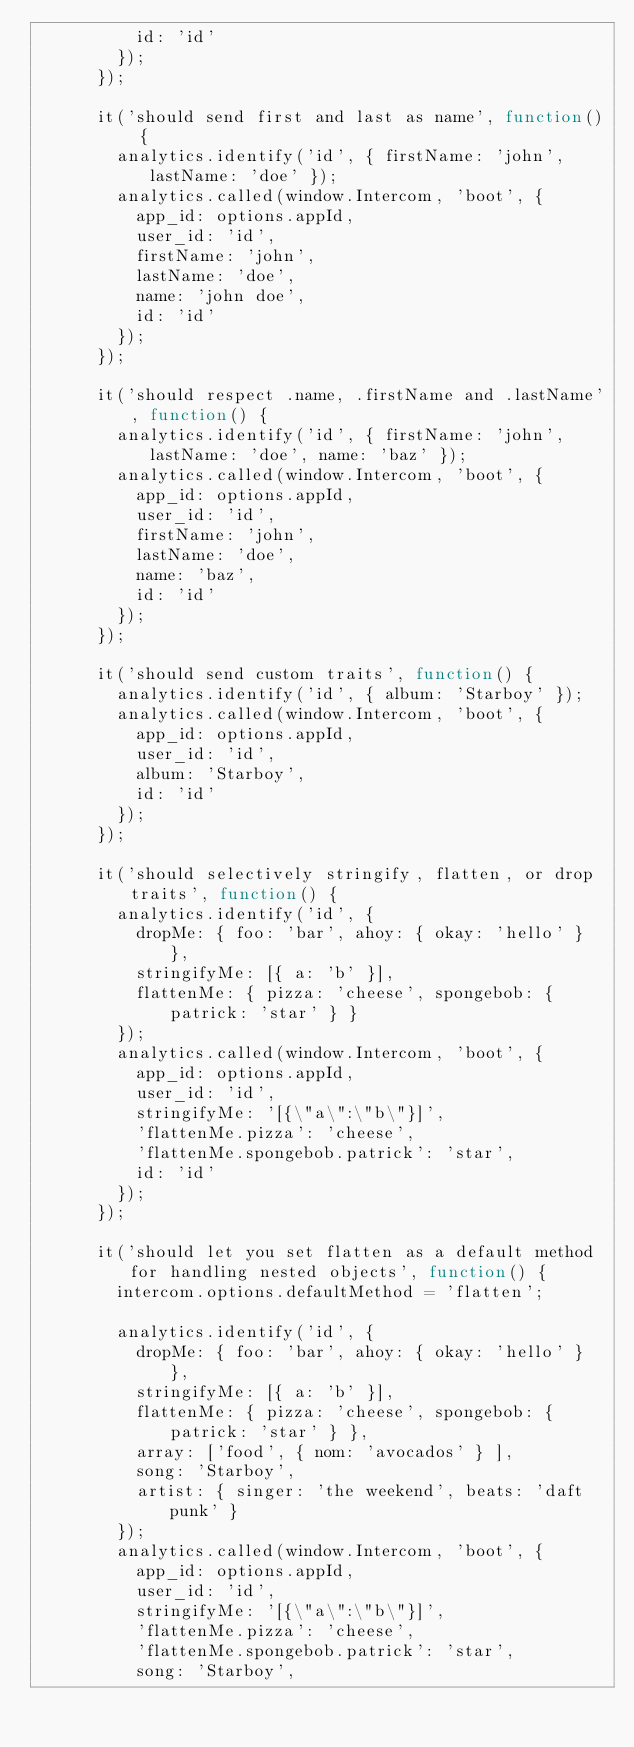Convert code to text. <code><loc_0><loc_0><loc_500><loc_500><_JavaScript_>          id: 'id'
        });
      });

      it('should send first and last as name', function() {
        analytics.identify('id', { firstName: 'john', lastName: 'doe' });
        analytics.called(window.Intercom, 'boot', {
          app_id: options.appId,
          user_id: 'id',
          firstName: 'john',
          lastName: 'doe',
          name: 'john doe',
          id: 'id'
        });
      });

      it('should respect .name, .firstName and .lastName', function() {
        analytics.identify('id', { firstName: 'john', lastName: 'doe', name: 'baz' });
        analytics.called(window.Intercom, 'boot', {
          app_id: options.appId,
          user_id: 'id',
          firstName: 'john',
          lastName: 'doe',
          name: 'baz',
          id: 'id'
        });
      });

      it('should send custom traits', function() {
        analytics.identify('id', { album: 'Starboy' });
        analytics.called(window.Intercom, 'boot', {
          app_id: options.appId,
          user_id: 'id',
          album: 'Starboy',
          id: 'id'
        });
      });

      it('should selectively stringify, flatten, or drop traits', function() {
        analytics.identify('id', {
          dropMe: { foo: 'bar', ahoy: { okay: 'hello' } },
          stringifyMe: [{ a: 'b' }],
          flattenMe: { pizza: 'cheese', spongebob: { patrick: 'star' } }
        });
        analytics.called(window.Intercom, 'boot', {
          app_id: options.appId,
          user_id: 'id',
          stringifyMe: '[{\"a\":\"b\"}]',
          'flattenMe.pizza': 'cheese',
          'flattenMe.spongebob.patrick': 'star',
          id: 'id'
        });
      });

      it('should let you set flatten as a default method for handling nested objects', function() {
        intercom.options.defaultMethod = 'flatten';

        analytics.identify('id', {
          dropMe: { foo: 'bar', ahoy: { okay: 'hello' } },
          stringifyMe: [{ a: 'b' }],
          flattenMe: { pizza: 'cheese', spongebob: { patrick: 'star' } },
          array: ['food', { nom: 'avocados' } ],
          song: 'Starboy',
          artist: { singer: 'the weekend', beats: 'daft punk' }
        });
        analytics.called(window.Intercom, 'boot', {
          app_id: options.appId,
          user_id: 'id',
          stringifyMe: '[{\"a\":\"b\"}]',
          'flattenMe.pizza': 'cheese',
          'flattenMe.spongebob.patrick': 'star',
          song: 'Starboy',</code> 